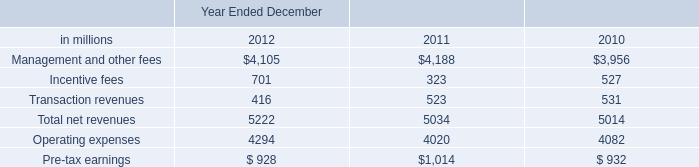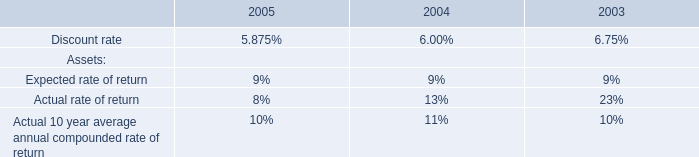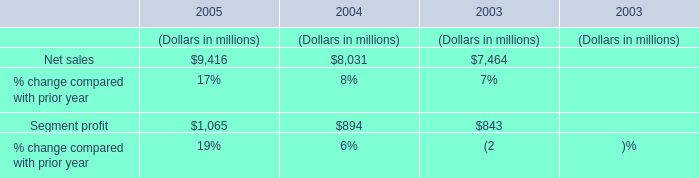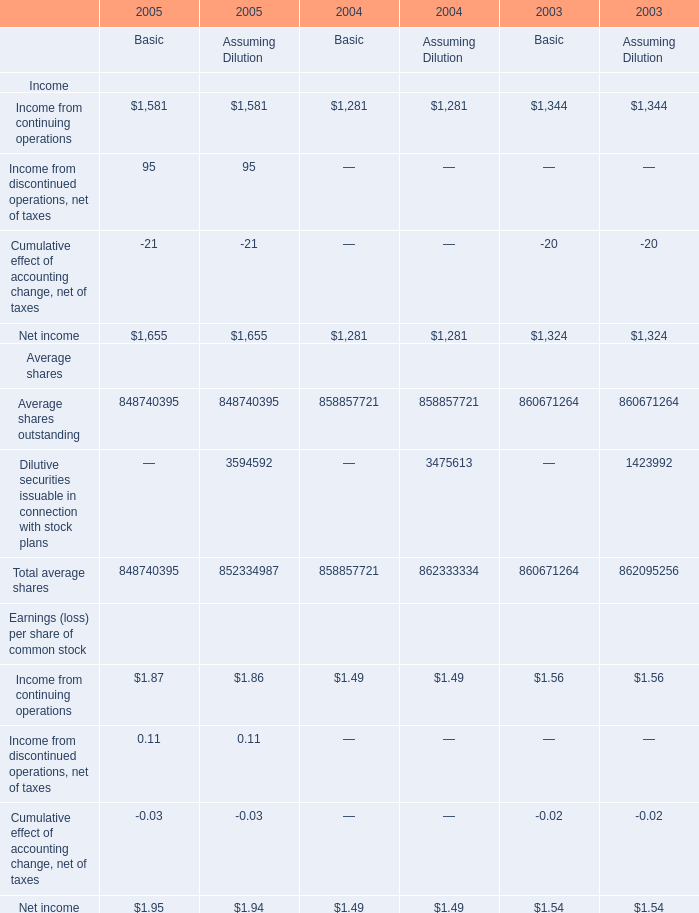What is the average amount of Income from continuing operations of 2004 Basic, and Operating expenses of Year Ended December 2012 ? 
Computations: ((1281.0 + 4294.0) / 2)
Answer: 2787.5. 